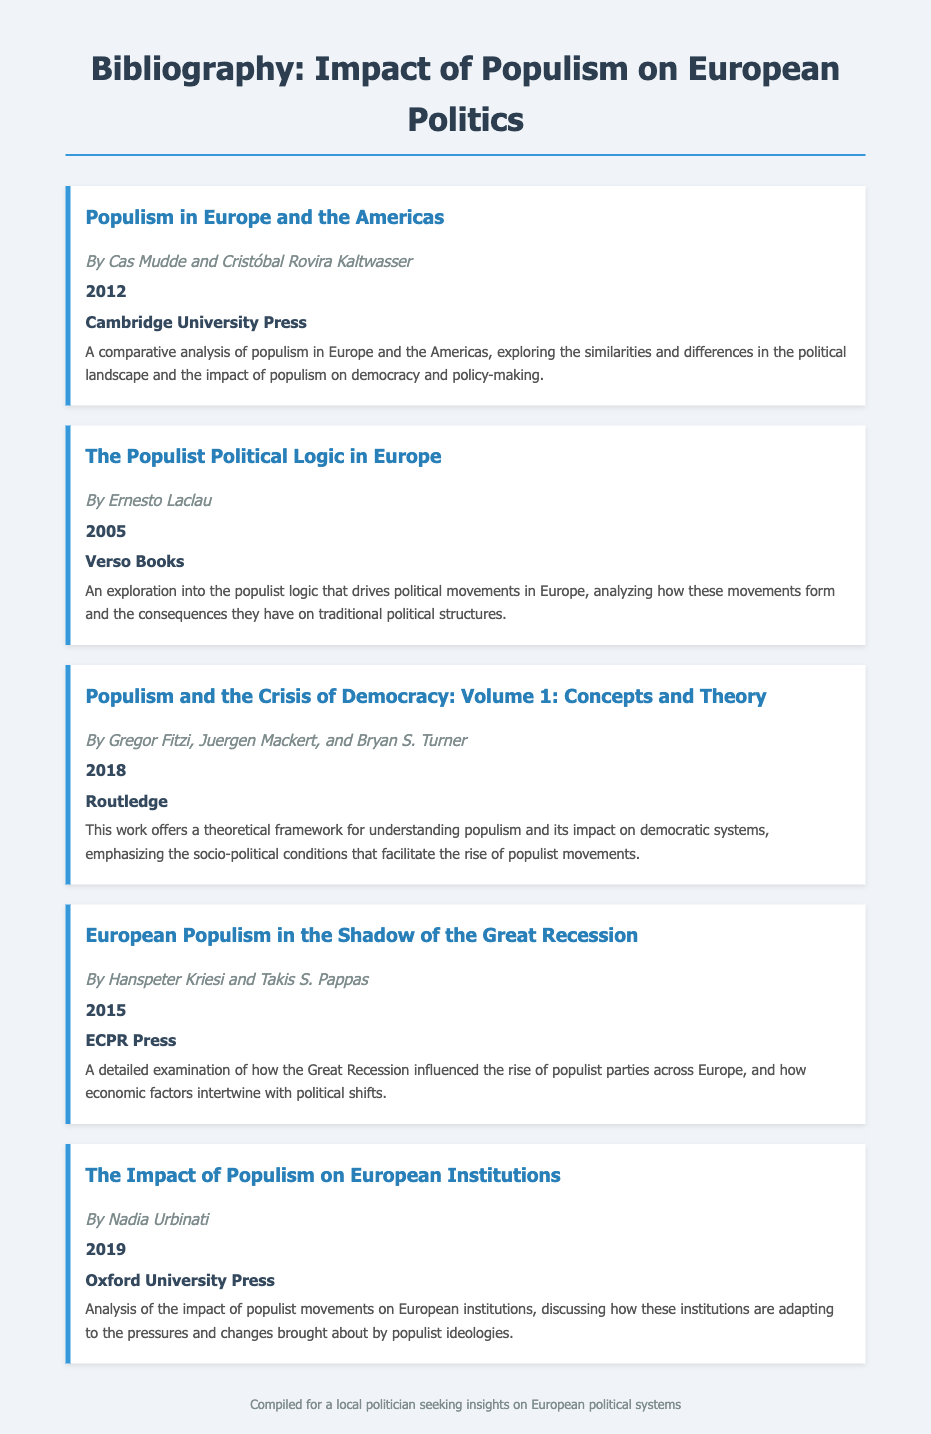What is the title of the first bibliographic entry? The title of the first entry is listed at the top of the item as "Populism in Europe and the Americas."
Answer: Populism in Europe and the Americas Who are the authors of the second bibliographic entry? The authors are specified right below the title in the second item: Ernesto Laclau.
Answer: Ernesto Laclau In what year was the book "European Populism in the Shadow of the Great Recession" published? The publication year is noted in bold after the author's name in the entry, which is 2015.
Answer: 2015 Which publisher released the book authored by Nadia Urbinati? The publisher name is provided in bold at the end of the bibliographic item for Urbinati's entry, which is Oxford University Press.
Answer: Oxford University Press What is the primary focus of the book "Populism and the Crisis of Democracy"? The summary of the item indicates that the primary focus is on the theoretical framework for understanding populism and its impact on democratic systems.
Answer: Theoretical framework for understanding populism How many authors contributed to the book "Populism and the Crisis of Democracy"? The number of authors can be derived from the authors’ names listed in the entry, which states there are three authors: Gregor Fitzi, Juergen Mackert, and Bryan S. Turner.
Answer: Three What is a key theme explored in "The Impact of Populism on European Institutions"? The summary for this entry mentions that it discusses the adaptation of European institutions to populist ideologies, identifying the central theme.
Answer: Adaptation of European institutions Which entry discusses the influence of the Great Recession on populist parties? This information can be found in the title of the entry that addresses economic influences, which is "European Populism in the Shadow of the Great Recession."
Answer: European Populism in the Shadow of the Great Recession What type of literature is this document? The structure and content of the document indicate that it is a bibliography, which organizes references related to a specific topic.
Answer: Bibliography 